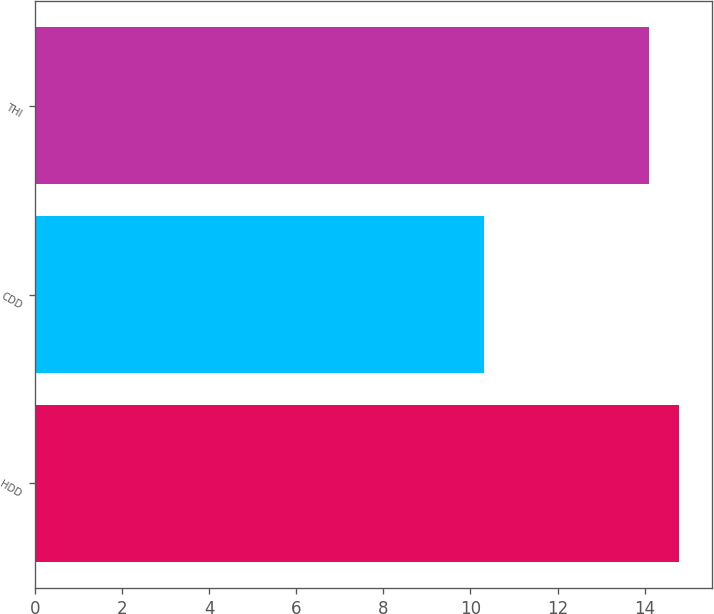<chart> <loc_0><loc_0><loc_500><loc_500><bar_chart><fcel>HDD<fcel>CDD<fcel>THI<nl><fcel>14.8<fcel>10.3<fcel>14.1<nl></chart> 